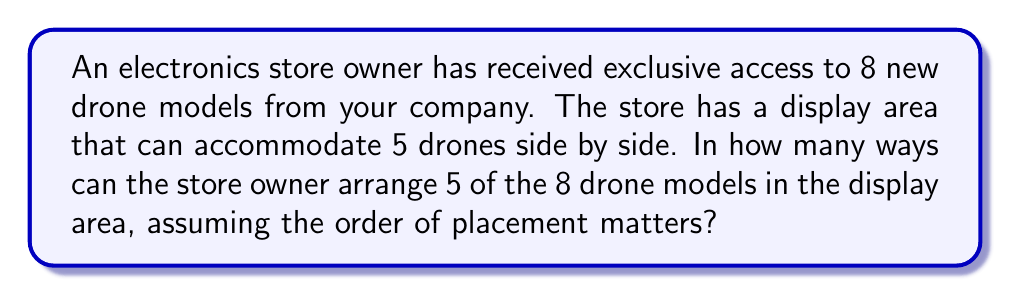Provide a solution to this math problem. Let's approach this step-by-step:

1) This is a permutation problem. We are selecting 5 drones out of 8 and arranging them in a specific order.

2) The formula for permutations is:

   $$P(n,r) = \frac{n!}{(n-r)!}$$

   Where $n$ is the total number of items to choose from, and $r$ is the number of items being chosen.

3) In this case, $n = 8$ (total number of drone models) and $r = 5$ (number of drones that can fit in the display).

4) Plugging these values into our formula:

   $$P(8,5) = \frac{8!}{(8-5)!} = \frac{8!}{3!}$$

5) Let's calculate this:
   
   $$\frac{8!}{3!} = \frac{8 \times 7 \times 6 \times 5 \times 4 \times 3!}{3!}$$

6) The $3!$ cancels out in the numerator and denominator:

   $$8 \times 7 \times 6 \times 5 \times 4 = 6720$$

Therefore, there are 6720 ways to arrange 5 out of the 8 drone models in the display area.
Answer: 6720 